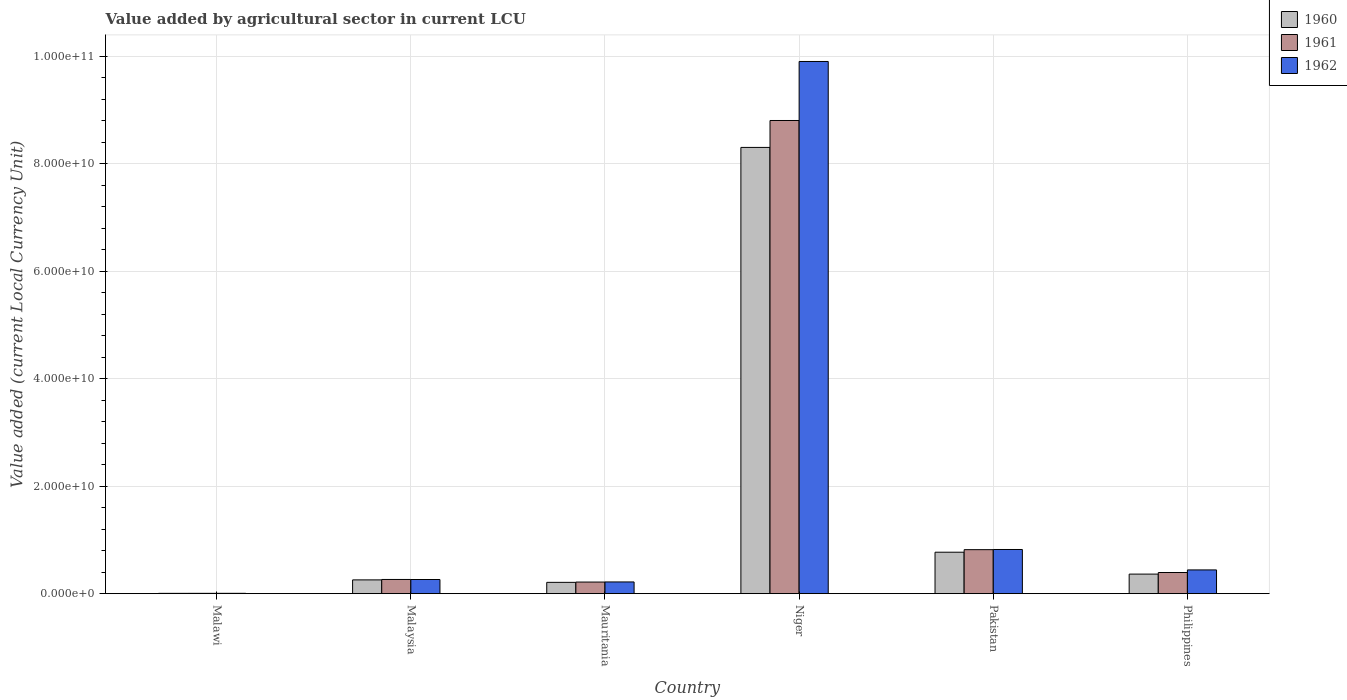How many groups of bars are there?
Offer a very short reply. 6. Are the number of bars per tick equal to the number of legend labels?
Ensure brevity in your answer.  Yes. How many bars are there on the 6th tick from the left?
Your answer should be very brief. 3. How many bars are there on the 6th tick from the right?
Your answer should be very brief. 3. What is the label of the 3rd group of bars from the left?
Your response must be concise. Mauritania. In how many cases, is the number of bars for a given country not equal to the number of legend labels?
Your answer should be compact. 0. What is the value added by agricultural sector in 1962 in Malaysia?
Provide a succinct answer. 2.63e+09. Across all countries, what is the maximum value added by agricultural sector in 1960?
Provide a succinct answer. 8.30e+1. Across all countries, what is the minimum value added by agricultural sector in 1961?
Offer a very short reply. 6.06e+07. In which country was the value added by agricultural sector in 1961 maximum?
Offer a terse response. Niger. In which country was the value added by agricultural sector in 1960 minimum?
Your response must be concise. Malawi. What is the total value added by agricultural sector in 1961 in the graph?
Your answer should be very brief. 1.05e+11. What is the difference between the value added by agricultural sector in 1962 in Malawi and that in Malaysia?
Your response must be concise. -2.57e+09. What is the difference between the value added by agricultural sector in 1962 in Mauritania and the value added by agricultural sector in 1960 in Niger?
Your answer should be compact. -8.08e+1. What is the average value added by agricultural sector in 1960 per country?
Provide a short and direct response. 1.65e+1. What is the difference between the value added by agricultural sector of/in 1962 and value added by agricultural sector of/in 1961 in Niger?
Offer a terse response. 1.10e+1. In how many countries, is the value added by agricultural sector in 1961 greater than 84000000000 LCU?
Your answer should be compact. 1. What is the ratio of the value added by agricultural sector in 1962 in Malawi to that in Malaysia?
Offer a terse response. 0.02. Is the difference between the value added by agricultural sector in 1962 in Malawi and Pakistan greater than the difference between the value added by agricultural sector in 1961 in Malawi and Pakistan?
Your answer should be compact. No. What is the difference between the highest and the second highest value added by agricultural sector in 1961?
Keep it short and to the point. -4.25e+09. What is the difference between the highest and the lowest value added by agricultural sector in 1961?
Offer a very short reply. 8.80e+1. What does the 2nd bar from the left in Niger represents?
Give a very brief answer. 1961. Is it the case that in every country, the sum of the value added by agricultural sector in 1961 and value added by agricultural sector in 1962 is greater than the value added by agricultural sector in 1960?
Offer a very short reply. Yes. How many bars are there?
Your answer should be very brief. 18. How many countries are there in the graph?
Ensure brevity in your answer.  6. What is the difference between two consecutive major ticks on the Y-axis?
Your response must be concise. 2.00e+1. Are the values on the major ticks of Y-axis written in scientific E-notation?
Provide a succinct answer. Yes. Does the graph contain any zero values?
Provide a succinct answer. No. Does the graph contain grids?
Keep it short and to the point. Yes. How are the legend labels stacked?
Your answer should be very brief. Vertical. What is the title of the graph?
Ensure brevity in your answer.  Value added by agricultural sector in current LCU. Does "1972" appear as one of the legend labels in the graph?
Provide a succinct answer. No. What is the label or title of the X-axis?
Your answer should be very brief. Country. What is the label or title of the Y-axis?
Offer a terse response. Value added (current Local Currency Unit). What is the Value added (current Local Currency Unit) in 1960 in Malawi?
Provide a succinct answer. 5.63e+07. What is the Value added (current Local Currency Unit) in 1961 in Malawi?
Ensure brevity in your answer.  6.06e+07. What is the Value added (current Local Currency Unit) in 1962 in Malawi?
Your answer should be very brief. 6.36e+07. What is the Value added (current Local Currency Unit) in 1960 in Malaysia?
Your answer should be very brief. 2.56e+09. What is the Value added (current Local Currency Unit) in 1961 in Malaysia?
Your response must be concise. 2.64e+09. What is the Value added (current Local Currency Unit) of 1962 in Malaysia?
Keep it short and to the point. 2.63e+09. What is the Value added (current Local Currency Unit) in 1960 in Mauritania?
Make the answer very short. 2.10e+09. What is the Value added (current Local Currency Unit) in 1961 in Mauritania?
Your response must be concise. 2.16e+09. What is the Value added (current Local Currency Unit) in 1962 in Mauritania?
Offer a very short reply. 2.18e+09. What is the Value added (current Local Currency Unit) in 1960 in Niger?
Your response must be concise. 8.30e+1. What is the Value added (current Local Currency Unit) in 1961 in Niger?
Provide a short and direct response. 8.80e+1. What is the Value added (current Local Currency Unit) in 1962 in Niger?
Offer a very short reply. 9.90e+1. What is the Value added (current Local Currency Unit) of 1960 in Pakistan?
Your answer should be very brief. 7.71e+09. What is the Value added (current Local Currency Unit) of 1961 in Pakistan?
Your answer should be compact. 8.18e+09. What is the Value added (current Local Currency Unit) of 1962 in Pakistan?
Your answer should be compact. 8.22e+09. What is the Value added (current Local Currency Unit) in 1960 in Philippines?
Ensure brevity in your answer.  3.64e+09. What is the Value added (current Local Currency Unit) of 1961 in Philippines?
Make the answer very short. 3.94e+09. What is the Value added (current Local Currency Unit) in 1962 in Philippines?
Keep it short and to the point. 4.42e+09. Across all countries, what is the maximum Value added (current Local Currency Unit) of 1960?
Offer a very short reply. 8.30e+1. Across all countries, what is the maximum Value added (current Local Currency Unit) of 1961?
Your answer should be very brief. 8.80e+1. Across all countries, what is the maximum Value added (current Local Currency Unit) in 1962?
Your answer should be very brief. 9.90e+1. Across all countries, what is the minimum Value added (current Local Currency Unit) of 1960?
Your response must be concise. 5.63e+07. Across all countries, what is the minimum Value added (current Local Currency Unit) in 1961?
Your answer should be compact. 6.06e+07. Across all countries, what is the minimum Value added (current Local Currency Unit) in 1962?
Offer a terse response. 6.36e+07. What is the total Value added (current Local Currency Unit) in 1960 in the graph?
Your answer should be very brief. 9.91e+1. What is the total Value added (current Local Currency Unit) of 1961 in the graph?
Ensure brevity in your answer.  1.05e+11. What is the total Value added (current Local Currency Unit) of 1962 in the graph?
Provide a short and direct response. 1.17e+11. What is the difference between the Value added (current Local Currency Unit) of 1960 in Malawi and that in Malaysia?
Ensure brevity in your answer.  -2.51e+09. What is the difference between the Value added (current Local Currency Unit) in 1961 in Malawi and that in Malaysia?
Keep it short and to the point. -2.58e+09. What is the difference between the Value added (current Local Currency Unit) in 1962 in Malawi and that in Malaysia?
Your response must be concise. -2.57e+09. What is the difference between the Value added (current Local Currency Unit) of 1960 in Malawi and that in Mauritania?
Your answer should be compact. -2.05e+09. What is the difference between the Value added (current Local Currency Unit) in 1961 in Malawi and that in Mauritania?
Give a very brief answer. -2.10e+09. What is the difference between the Value added (current Local Currency Unit) in 1962 in Malawi and that in Mauritania?
Your answer should be very brief. -2.12e+09. What is the difference between the Value added (current Local Currency Unit) in 1960 in Malawi and that in Niger?
Keep it short and to the point. -8.30e+1. What is the difference between the Value added (current Local Currency Unit) of 1961 in Malawi and that in Niger?
Offer a very short reply. -8.80e+1. What is the difference between the Value added (current Local Currency Unit) of 1962 in Malawi and that in Niger?
Ensure brevity in your answer.  -9.89e+1. What is the difference between the Value added (current Local Currency Unit) of 1960 in Malawi and that in Pakistan?
Your answer should be very brief. -7.65e+09. What is the difference between the Value added (current Local Currency Unit) of 1961 in Malawi and that in Pakistan?
Offer a very short reply. -8.12e+09. What is the difference between the Value added (current Local Currency Unit) in 1962 in Malawi and that in Pakistan?
Provide a succinct answer. -8.15e+09. What is the difference between the Value added (current Local Currency Unit) in 1960 in Malawi and that in Philippines?
Your answer should be very brief. -3.58e+09. What is the difference between the Value added (current Local Currency Unit) in 1961 in Malawi and that in Philippines?
Ensure brevity in your answer.  -3.87e+09. What is the difference between the Value added (current Local Currency Unit) of 1962 in Malawi and that in Philippines?
Provide a succinct answer. -4.35e+09. What is the difference between the Value added (current Local Currency Unit) in 1960 in Malaysia and that in Mauritania?
Ensure brevity in your answer.  4.61e+08. What is the difference between the Value added (current Local Currency Unit) in 1961 in Malaysia and that in Mauritania?
Keep it short and to the point. 4.82e+08. What is the difference between the Value added (current Local Currency Unit) in 1962 in Malaysia and that in Mauritania?
Give a very brief answer. 4.54e+08. What is the difference between the Value added (current Local Currency Unit) in 1960 in Malaysia and that in Niger?
Ensure brevity in your answer.  -8.05e+1. What is the difference between the Value added (current Local Currency Unit) in 1961 in Malaysia and that in Niger?
Give a very brief answer. -8.54e+1. What is the difference between the Value added (current Local Currency Unit) of 1962 in Malaysia and that in Niger?
Offer a terse response. -9.64e+1. What is the difference between the Value added (current Local Currency Unit) in 1960 in Malaysia and that in Pakistan?
Provide a succinct answer. -5.15e+09. What is the difference between the Value added (current Local Currency Unit) in 1961 in Malaysia and that in Pakistan?
Keep it short and to the point. -5.54e+09. What is the difference between the Value added (current Local Currency Unit) in 1962 in Malaysia and that in Pakistan?
Offer a terse response. -5.58e+09. What is the difference between the Value added (current Local Currency Unit) in 1960 in Malaysia and that in Philippines?
Give a very brief answer. -1.07e+09. What is the difference between the Value added (current Local Currency Unit) of 1961 in Malaysia and that in Philippines?
Provide a succinct answer. -1.29e+09. What is the difference between the Value added (current Local Currency Unit) in 1962 in Malaysia and that in Philippines?
Ensure brevity in your answer.  -1.78e+09. What is the difference between the Value added (current Local Currency Unit) of 1960 in Mauritania and that in Niger?
Your response must be concise. -8.09e+1. What is the difference between the Value added (current Local Currency Unit) of 1961 in Mauritania and that in Niger?
Provide a short and direct response. -8.59e+1. What is the difference between the Value added (current Local Currency Unit) in 1962 in Mauritania and that in Niger?
Keep it short and to the point. -9.68e+1. What is the difference between the Value added (current Local Currency Unit) of 1960 in Mauritania and that in Pakistan?
Your response must be concise. -5.61e+09. What is the difference between the Value added (current Local Currency Unit) of 1961 in Mauritania and that in Pakistan?
Keep it short and to the point. -6.02e+09. What is the difference between the Value added (current Local Currency Unit) of 1962 in Mauritania and that in Pakistan?
Make the answer very short. -6.04e+09. What is the difference between the Value added (current Local Currency Unit) of 1960 in Mauritania and that in Philippines?
Keep it short and to the point. -1.54e+09. What is the difference between the Value added (current Local Currency Unit) of 1961 in Mauritania and that in Philippines?
Keep it short and to the point. -1.78e+09. What is the difference between the Value added (current Local Currency Unit) in 1962 in Mauritania and that in Philippines?
Provide a short and direct response. -2.24e+09. What is the difference between the Value added (current Local Currency Unit) in 1960 in Niger and that in Pakistan?
Ensure brevity in your answer.  7.53e+1. What is the difference between the Value added (current Local Currency Unit) of 1961 in Niger and that in Pakistan?
Provide a succinct answer. 7.98e+1. What is the difference between the Value added (current Local Currency Unit) of 1962 in Niger and that in Pakistan?
Provide a short and direct response. 9.08e+1. What is the difference between the Value added (current Local Currency Unit) of 1960 in Niger and that in Philippines?
Ensure brevity in your answer.  7.94e+1. What is the difference between the Value added (current Local Currency Unit) in 1961 in Niger and that in Philippines?
Provide a succinct answer. 8.41e+1. What is the difference between the Value added (current Local Currency Unit) in 1962 in Niger and that in Philippines?
Keep it short and to the point. 9.46e+1. What is the difference between the Value added (current Local Currency Unit) of 1960 in Pakistan and that in Philippines?
Offer a very short reply. 4.07e+09. What is the difference between the Value added (current Local Currency Unit) of 1961 in Pakistan and that in Philippines?
Your answer should be very brief. 4.25e+09. What is the difference between the Value added (current Local Currency Unit) of 1962 in Pakistan and that in Philippines?
Provide a succinct answer. 3.80e+09. What is the difference between the Value added (current Local Currency Unit) of 1960 in Malawi and the Value added (current Local Currency Unit) of 1961 in Malaysia?
Make the answer very short. -2.59e+09. What is the difference between the Value added (current Local Currency Unit) in 1960 in Malawi and the Value added (current Local Currency Unit) in 1962 in Malaysia?
Ensure brevity in your answer.  -2.58e+09. What is the difference between the Value added (current Local Currency Unit) in 1961 in Malawi and the Value added (current Local Currency Unit) in 1962 in Malaysia?
Your answer should be very brief. -2.57e+09. What is the difference between the Value added (current Local Currency Unit) of 1960 in Malawi and the Value added (current Local Currency Unit) of 1961 in Mauritania?
Make the answer very short. -2.10e+09. What is the difference between the Value added (current Local Currency Unit) in 1960 in Malawi and the Value added (current Local Currency Unit) in 1962 in Mauritania?
Your answer should be very brief. -2.12e+09. What is the difference between the Value added (current Local Currency Unit) of 1961 in Malawi and the Value added (current Local Currency Unit) of 1962 in Mauritania?
Provide a succinct answer. -2.12e+09. What is the difference between the Value added (current Local Currency Unit) of 1960 in Malawi and the Value added (current Local Currency Unit) of 1961 in Niger?
Your response must be concise. -8.80e+1. What is the difference between the Value added (current Local Currency Unit) of 1960 in Malawi and the Value added (current Local Currency Unit) of 1962 in Niger?
Offer a very short reply. -9.90e+1. What is the difference between the Value added (current Local Currency Unit) of 1961 in Malawi and the Value added (current Local Currency Unit) of 1962 in Niger?
Give a very brief answer. -9.90e+1. What is the difference between the Value added (current Local Currency Unit) of 1960 in Malawi and the Value added (current Local Currency Unit) of 1961 in Pakistan?
Your response must be concise. -8.13e+09. What is the difference between the Value added (current Local Currency Unit) in 1960 in Malawi and the Value added (current Local Currency Unit) in 1962 in Pakistan?
Ensure brevity in your answer.  -8.16e+09. What is the difference between the Value added (current Local Currency Unit) in 1961 in Malawi and the Value added (current Local Currency Unit) in 1962 in Pakistan?
Your answer should be very brief. -8.16e+09. What is the difference between the Value added (current Local Currency Unit) of 1960 in Malawi and the Value added (current Local Currency Unit) of 1961 in Philippines?
Offer a very short reply. -3.88e+09. What is the difference between the Value added (current Local Currency Unit) in 1960 in Malawi and the Value added (current Local Currency Unit) in 1962 in Philippines?
Provide a short and direct response. -4.36e+09. What is the difference between the Value added (current Local Currency Unit) in 1961 in Malawi and the Value added (current Local Currency Unit) in 1962 in Philippines?
Provide a succinct answer. -4.36e+09. What is the difference between the Value added (current Local Currency Unit) of 1960 in Malaysia and the Value added (current Local Currency Unit) of 1961 in Mauritania?
Provide a succinct answer. 4.04e+08. What is the difference between the Value added (current Local Currency Unit) in 1960 in Malaysia and the Value added (current Local Currency Unit) in 1962 in Mauritania?
Provide a short and direct response. 3.86e+08. What is the difference between the Value added (current Local Currency Unit) in 1961 in Malaysia and the Value added (current Local Currency Unit) in 1962 in Mauritania?
Keep it short and to the point. 4.63e+08. What is the difference between the Value added (current Local Currency Unit) in 1960 in Malaysia and the Value added (current Local Currency Unit) in 1961 in Niger?
Keep it short and to the point. -8.55e+1. What is the difference between the Value added (current Local Currency Unit) in 1960 in Malaysia and the Value added (current Local Currency Unit) in 1962 in Niger?
Give a very brief answer. -9.64e+1. What is the difference between the Value added (current Local Currency Unit) in 1961 in Malaysia and the Value added (current Local Currency Unit) in 1962 in Niger?
Your answer should be compact. -9.64e+1. What is the difference between the Value added (current Local Currency Unit) in 1960 in Malaysia and the Value added (current Local Currency Unit) in 1961 in Pakistan?
Offer a very short reply. -5.62e+09. What is the difference between the Value added (current Local Currency Unit) of 1960 in Malaysia and the Value added (current Local Currency Unit) of 1962 in Pakistan?
Your response must be concise. -5.65e+09. What is the difference between the Value added (current Local Currency Unit) in 1961 in Malaysia and the Value added (current Local Currency Unit) in 1962 in Pakistan?
Offer a terse response. -5.57e+09. What is the difference between the Value added (current Local Currency Unit) of 1960 in Malaysia and the Value added (current Local Currency Unit) of 1961 in Philippines?
Offer a terse response. -1.37e+09. What is the difference between the Value added (current Local Currency Unit) of 1960 in Malaysia and the Value added (current Local Currency Unit) of 1962 in Philippines?
Offer a terse response. -1.85e+09. What is the difference between the Value added (current Local Currency Unit) of 1961 in Malaysia and the Value added (current Local Currency Unit) of 1962 in Philippines?
Make the answer very short. -1.77e+09. What is the difference between the Value added (current Local Currency Unit) in 1960 in Mauritania and the Value added (current Local Currency Unit) in 1961 in Niger?
Offer a very short reply. -8.59e+1. What is the difference between the Value added (current Local Currency Unit) of 1960 in Mauritania and the Value added (current Local Currency Unit) of 1962 in Niger?
Provide a succinct answer. -9.69e+1. What is the difference between the Value added (current Local Currency Unit) of 1961 in Mauritania and the Value added (current Local Currency Unit) of 1962 in Niger?
Make the answer very short. -9.69e+1. What is the difference between the Value added (current Local Currency Unit) of 1960 in Mauritania and the Value added (current Local Currency Unit) of 1961 in Pakistan?
Provide a short and direct response. -6.08e+09. What is the difference between the Value added (current Local Currency Unit) of 1960 in Mauritania and the Value added (current Local Currency Unit) of 1962 in Pakistan?
Provide a short and direct response. -6.11e+09. What is the difference between the Value added (current Local Currency Unit) of 1961 in Mauritania and the Value added (current Local Currency Unit) of 1962 in Pakistan?
Make the answer very short. -6.06e+09. What is the difference between the Value added (current Local Currency Unit) of 1960 in Mauritania and the Value added (current Local Currency Unit) of 1961 in Philippines?
Keep it short and to the point. -1.83e+09. What is the difference between the Value added (current Local Currency Unit) in 1960 in Mauritania and the Value added (current Local Currency Unit) in 1962 in Philippines?
Your answer should be very brief. -2.31e+09. What is the difference between the Value added (current Local Currency Unit) in 1961 in Mauritania and the Value added (current Local Currency Unit) in 1962 in Philippines?
Give a very brief answer. -2.26e+09. What is the difference between the Value added (current Local Currency Unit) of 1960 in Niger and the Value added (current Local Currency Unit) of 1961 in Pakistan?
Provide a short and direct response. 7.48e+1. What is the difference between the Value added (current Local Currency Unit) in 1960 in Niger and the Value added (current Local Currency Unit) in 1962 in Pakistan?
Make the answer very short. 7.48e+1. What is the difference between the Value added (current Local Currency Unit) of 1961 in Niger and the Value added (current Local Currency Unit) of 1962 in Pakistan?
Make the answer very short. 7.98e+1. What is the difference between the Value added (current Local Currency Unit) in 1960 in Niger and the Value added (current Local Currency Unit) in 1961 in Philippines?
Keep it short and to the point. 7.91e+1. What is the difference between the Value added (current Local Currency Unit) in 1960 in Niger and the Value added (current Local Currency Unit) in 1962 in Philippines?
Make the answer very short. 7.86e+1. What is the difference between the Value added (current Local Currency Unit) of 1961 in Niger and the Value added (current Local Currency Unit) of 1962 in Philippines?
Make the answer very short. 8.36e+1. What is the difference between the Value added (current Local Currency Unit) in 1960 in Pakistan and the Value added (current Local Currency Unit) in 1961 in Philippines?
Offer a terse response. 3.78e+09. What is the difference between the Value added (current Local Currency Unit) in 1960 in Pakistan and the Value added (current Local Currency Unit) in 1962 in Philippines?
Make the answer very short. 3.29e+09. What is the difference between the Value added (current Local Currency Unit) in 1961 in Pakistan and the Value added (current Local Currency Unit) in 1962 in Philippines?
Offer a terse response. 3.77e+09. What is the average Value added (current Local Currency Unit) of 1960 per country?
Provide a short and direct response. 1.65e+1. What is the average Value added (current Local Currency Unit) in 1961 per country?
Your response must be concise. 1.75e+1. What is the average Value added (current Local Currency Unit) in 1962 per country?
Keep it short and to the point. 1.94e+1. What is the difference between the Value added (current Local Currency Unit) of 1960 and Value added (current Local Currency Unit) of 1961 in Malawi?
Keep it short and to the point. -4.30e+06. What is the difference between the Value added (current Local Currency Unit) of 1960 and Value added (current Local Currency Unit) of 1962 in Malawi?
Your answer should be very brief. -7.30e+06. What is the difference between the Value added (current Local Currency Unit) of 1960 and Value added (current Local Currency Unit) of 1961 in Malaysia?
Provide a succinct answer. -7.78e+07. What is the difference between the Value added (current Local Currency Unit) of 1960 and Value added (current Local Currency Unit) of 1962 in Malaysia?
Provide a succinct answer. -6.83e+07. What is the difference between the Value added (current Local Currency Unit) of 1961 and Value added (current Local Currency Unit) of 1962 in Malaysia?
Offer a very short reply. 9.46e+06. What is the difference between the Value added (current Local Currency Unit) of 1960 and Value added (current Local Currency Unit) of 1961 in Mauritania?
Make the answer very short. -5.68e+07. What is the difference between the Value added (current Local Currency Unit) in 1960 and Value added (current Local Currency Unit) in 1962 in Mauritania?
Provide a succinct answer. -7.58e+07. What is the difference between the Value added (current Local Currency Unit) of 1961 and Value added (current Local Currency Unit) of 1962 in Mauritania?
Provide a succinct answer. -1.89e+07. What is the difference between the Value added (current Local Currency Unit) of 1960 and Value added (current Local Currency Unit) of 1961 in Niger?
Your response must be concise. -5.01e+09. What is the difference between the Value added (current Local Currency Unit) in 1960 and Value added (current Local Currency Unit) in 1962 in Niger?
Give a very brief answer. -1.60e+1. What is the difference between the Value added (current Local Currency Unit) in 1961 and Value added (current Local Currency Unit) in 1962 in Niger?
Provide a succinct answer. -1.10e+1. What is the difference between the Value added (current Local Currency Unit) in 1960 and Value added (current Local Currency Unit) in 1961 in Pakistan?
Ensure brevity in your answer.  -4.73e+08. What is the difference between the Value added (current Local Currency Unit) of 1960 and Value added (current Local Currency Unit) of 1962 in Pakistan?
Your answer should be compact. -5.05e+08. What is the difference between the Value added (current Local Currency Unit) in 1961 and Value added (current Local Currency Unit) in 1962 in Pakistan?
Offer a very short reply. -3.20e+07. What is the difference between the Value added (current Local Currency Unit) in 1960 and Value added (current Local Currency Unit) in 1961 in Philippines?
Offer a terse response. -2.97e+08. What is the difference between the Value added (current Local Currency Unit) of 1960 and Value added (current Local Currency Unit) of 1962 in Philippines?
Keep it short and to the point. -7.78e+08. What is the difference between the Value added (current Local Currency Unit) of 1961 and Value added (current Local Currency Unit) of 1962 in Philippines?
Your response must be concise. -4.81e+08. What is the ratio of the Value added (current Local Currency Unit) of 1960 in Malawi to that in Malaysia?
Offer a very short reply. 0.02. What is the ratio of the Value added (current Local Currency Unit) in 1961 in Malawi to that in Malaysia?
Your answer should be very brief. 0.02. What is the ratio of the Value added (current Local Currency Unit) of 1962 in Malawi to that in Malaysia?
Your response must be concise. 0.02. What is the ratio of the Value added (current Local Currency Unit) of 1960 in Malawi to that in Mauritania?
Keep it short and to the point. 0.03. What is the ratio of the Value added (current Local Currency Unit) of 1961 in Malawi to that in Mauritania?
Offer a terse response. 0.03. What is the ratio of the Value added (current Local Currency Unit) in 1962 in Malawi to that in Mauritania?
Give a very brief answer. 0.03. What is the ratio of the Value added (current Local Currency Unit) of 1960 in Malawi to that in Niger?
Make the answer very short. 0. What is the ratio of the Value added (current Local Currency Unit) in 1961 in Malawi to that in Niger?
Provide a succinct answer. 0. What is the ratio of the Value added (current Local Currency Unit) in 1962 in Malawi to that in Niger?
Your answer should be compact. 0. What is the ratio of the Value added (current Local Currency Unit) in 1960 in Malawi to that in Pakistan?
Your answer should be compact. 0.01. What is the ratio of the Value added (current Local Currency Unit) in 1961 in Malawi to that in Pakistan?
Give a very brief answer. 0.01. What is the ratio of the Value added (current Local Currency Unit) in 1962 in Malawi to that in Pakistan?
Provide a short and direct response. 0.01. What is the ratio of the Value added (current Local Currency Unit) in 1960 in Malawi to that in Philippines?
Offer a very short reply. 0.02. What is the ratio of the Value added (current Local Currency Unit) in 1961 in Malawi to that in Philippines?
Make the answer very short. 0.02. What is the ratio of the Value added (current Local Currency Unit) in 1962 in Malawi to that in Philippines?
Provide a short and direct response. 0.01. What is the ratio of the Value added (current Local Currency Unit) of 1960 in Malaysia to that in Mauritania?
Give a very brief answer. 1.22. What is the ratio of the Value added (current Local Currency Unit) in 1961 in Malaysia to that in Mauritania?
Your answer should be very brief. 1.22. What is the ratio of the Value added (current Local Currency Unit) of 1962 in Malaysia to that in Mauritania?
Offer a terse response. 1.21. What is the ratio of the Value added (current Local Currency Unit) in 1960 in Malaysia to that in Niger?
Ensure brevity in your answer.  0.03. What is the ratio of the Value added (current Local Currency Unit) of 1961 in Malaysia to that in Niger?
Your response must be concise. 0.03. What is the ratio of the Value added (current Local Currency Unit) of 1962 in Malaysia to that in Niger?
Keep it short and to the point. 0.03. What is the ratio of the Value added (current Local Currency Unit) of 1960 in Malaysia to that in Pakistan?
Offer a very short reply. 0.33. What is the ratio of the Value added (current Local Currency Unit) of 1961 in Malaysia to that in Pakistan?
Provide a short and direct response. 0.32. What is the ratio of the Value added (current Local Currency Unit) of 1962 in Malaysia to that in Pakistan?
Your answer should be compact. 0.32. What is the ratio of the Value added (current Local Currency Unit) of 1960 in Malaysia to that in Philippines?
Offer a very short reply. 0.7. What is the ratio of the Value added (current Local Currency Unit) in 1961 in Malaysia to that in Philippines?
Keep it short and to the point. 0.67. What is the ratio of the Value added (current Local Currency Unit) in 1962 in Malaysia to that in Philippines?
Your answer should be very brief. 0.6. What is the ratio of the Value added (current Local Currency Unit) in 1960 in Mauritania to that in Niger?
Ensure brevity in your answer.  0.03. What is the ratio of the Value added (current Local Currency Unit) of 1961 in Mauritania to that in Niger?
Provide a short and direct response. 0.02. What is the ratio of the Value added (current Local Currency Unit) of 1962 in Mauritania to that in Niger?
Your answer should be very brief. 0.02. What is the ratio of the Value added (current Local Currency Unit) of 1960 in Mauritania to that in Pakistan?
Offer a very short reply. 0.27. What is the ratio of the Value added (current Local Currency Unit) in 1961 in Mauritania to that in Pakistan?
Offer a very short reply. 0.26. What is the ratio of the Value added (current Local Currency Unit) in 1962 in Mauritania to that in Pakistan?
Offer a terse response. 0.27. What is the ratio of the Value added (current Local Currency Unit) of 1960 in Mauritania to that in Philippines?
Your answer should be very brief. 0.58. What is the ratio of the Value added (current Local Currency Unit) in 1961 in Mauritania to that in Philippines?
Offer a terse response. 0.55. What is the ratio of the Value added (current Local Currency Unit) in 1962 in Mauritania to that in Philippines?
Offer a very short reply. 0.49. What is the ratio of the Value added (current Local Currency Unit) of 1960 in Niger to that in Pakistan?
Keep it short and to the point. 10.77. What is the ratio of the Value added (current Local Currency Unit) of 1961 in Niger to that in Pakistan?
Offer a terse response. 10.76. What is the ratio of the Value added (current Local Currency Unit) of 1962 in Niger to that in Pakistan?
Offer a terse response. 12.05. What is the ratio of the Value added (current Local Currency Unit) of 1960 in Niger to that in Philippines?
Give a very brief answer. 22.82. What is the ratio of the Value added (current Local Currency Unit) in 1961 in Niger to that in Philippines?
Offer a terse response. 22.37. What is the ratio of the Value added (current Local Currency Unit) of 1962 in Niger to that in Philippines?
Make the answer very short. 22.42. What is the ratio of the Value added (current Local Currency Unit) in 1960 in Pakistan to that in Philippines?
Keep it short and to the point. 2.12. What is the ratio of the Value added (current Local Currency Unit) in 1961 in Pakistan to that in Philippines?
Offer a very short reply. 2.08. What is the ratio of the Value added (current Local Currency Unit) of 1962 in Pakistan to that in Philippines?
Ensure brevity in your answer.  1.86. What is the difference between the highest and the second highest Value added (current Local Currency Unit) of 1960?
Your response must be concise. 7.53e+1. What is the difference between the highest and the second highest Value added (current Local Currency Unit) of 1961?
Your answer should be very brief. 7.98e+1. What is the difference between the highest and the second highest Value added (current Local Currency Unit) of 1962?
Offer a terse response. 9.08e+1. What is the difference between the highest and the lowest Value added (current Local Currency Unit) of 1960?
Your answer should be compact. 8.30e+1. What is the difference between the highest and the lowest Value added (current Local Currency Unit) in 1961?
Offer a very short reply. 8.80e+1. What is the difference between the highest and the lowest Value added (current Local Currency Unit) of 1962?
Your response must be concise. 9.89e+1. 